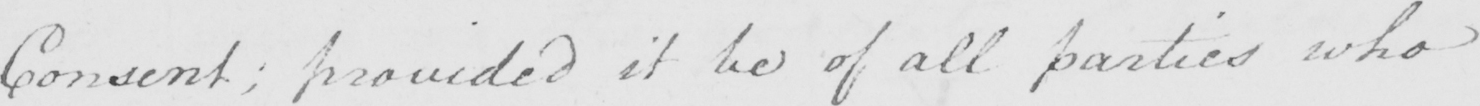Can you tell me what this handwritten text says? Consent ; provided it be of all parties who 